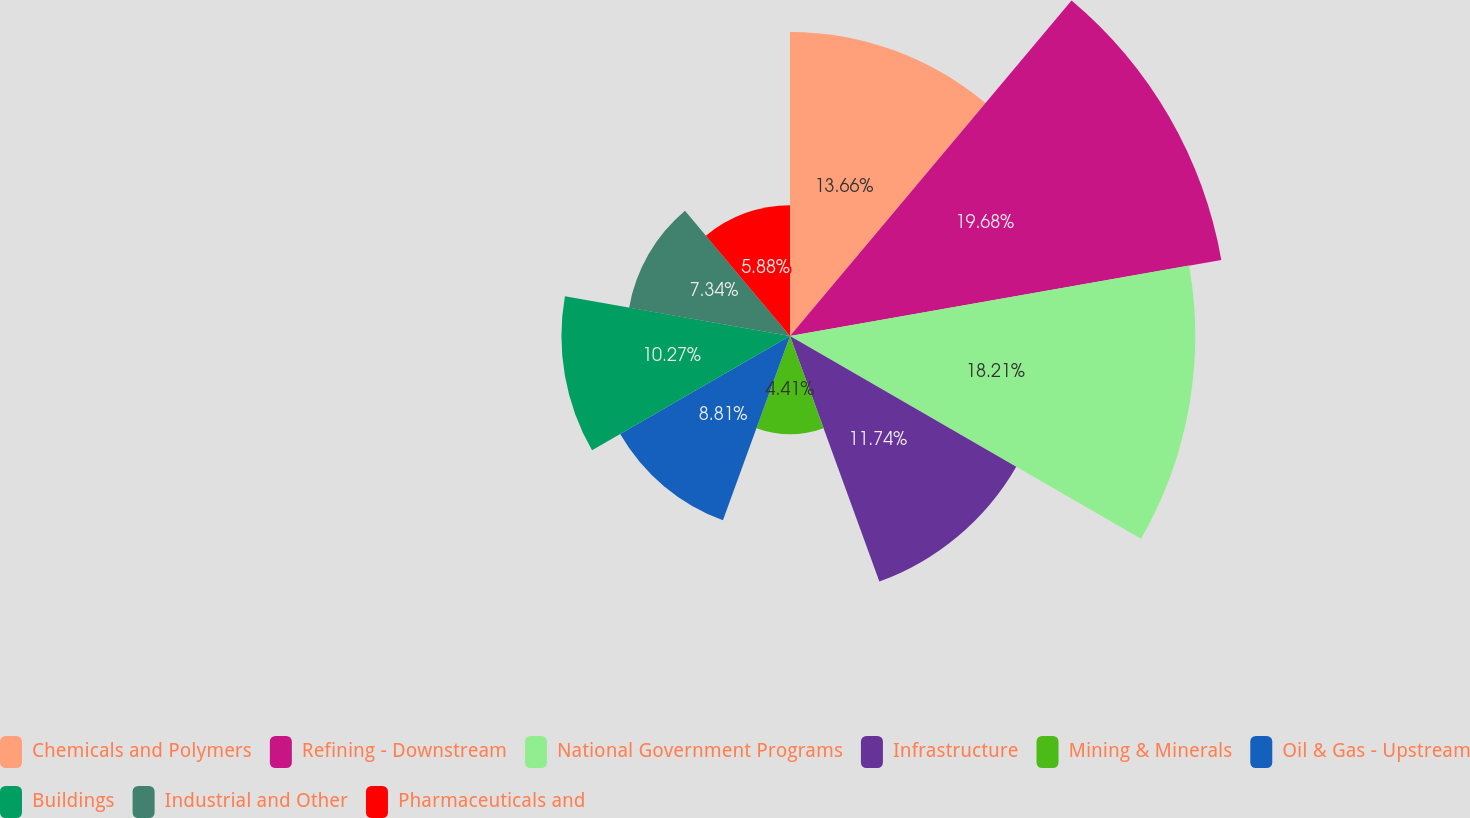Convert chart. <chart><loc_0><loc_0><loc_500><loc_500><pie_chart><fcel>Chemicals and Polymers<fcel>Refining - Downstream<fcel>National Government Programs<fcel>Infrastructure<fcel>Mining & Minerals<fcel>Oil & Gas - Upstream<fcel>Buildings<fcel>Industrial and Other<fcel>Pharmaceuticals and<nl><fcel>13.66%<fcel>19.68%<fcel>18.21%<fcel>11.74%<fcel>4.41%<fcel>8.81%<fcel>10.27%<fcel>7.34%<fcel>5.88%<nl></chart> 